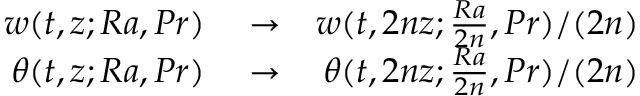<formula> <loc_0><loc_0><loc_500><loc_500>\begin{array} { r l r } { w ( t , z ; R a , P r ) } & \to } & { w ( t , 2 n z ; \frac { R a } { 2 n } , P r ) / ( 2 n ) } \\ { \theta ( t , z ; R a , P r ) } & \to } & { \theta ( t , 2 n z ; \frac { R a } { 2 n } , P r ) / ( 2 n ) } \end{array}</formula> 